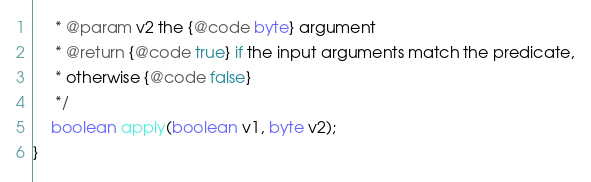Convert code to text. <code><loc_0><loc_0><loc_500><loc_500><_Java_>     * @param v2 the {@code byte} argument
     * @return {@code true} if the input arguments match the predicate,
     * otherwise {@code false}
     */
    boolean apply(boolean v1, byte v2);
}
</code> 